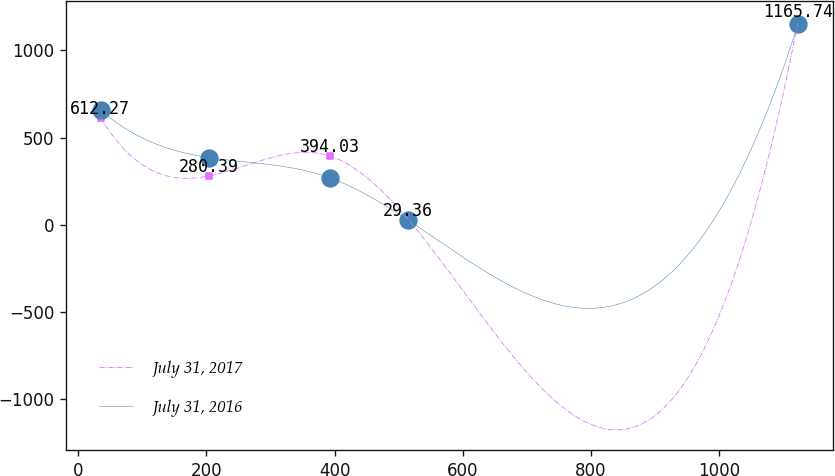Convert chart to OTSL. <chart><loc_0><loc_0><loc_500><loc_500><line_chart><ecel><fcel>July 31, 2017<fcel>July 31, 2016<nl><fcel>35.28<fcel>612.27<fcel>656.66<nl><fcel>204.6<fcel>280.39<fcel>385.07<nl><fcel>392.79<fcel>394.03<fcel>269.04<nl><fcel>515.21<fcel>29.36<fcel>25.66<nl><fcel>1123.17<fcel>1165.74<fcel>1151.29<nl></chart> 